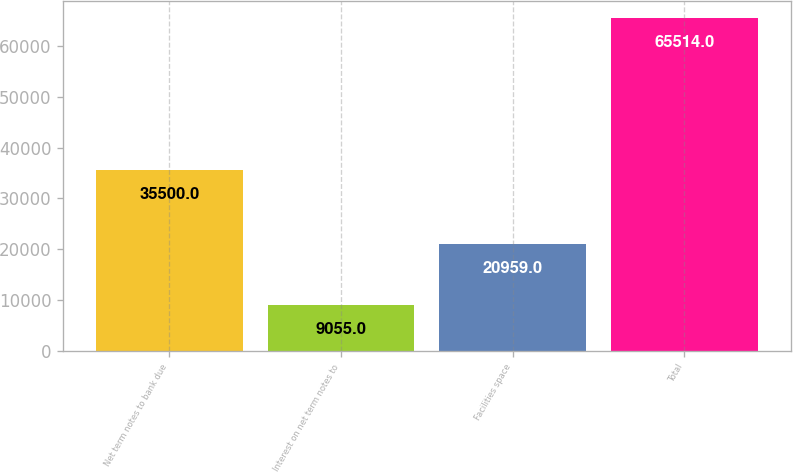Convert chart. <chart><loc_0><loc_0><loc_500><loc_500><bar_chart><fcel>Net term notes to bank due<fcel>Interest on net term notes to<fcel>Facilities space<fcel>Total<nl><fcel>35500<fcel>9055<fcel>20959<fcel>65514<nl></chart> 